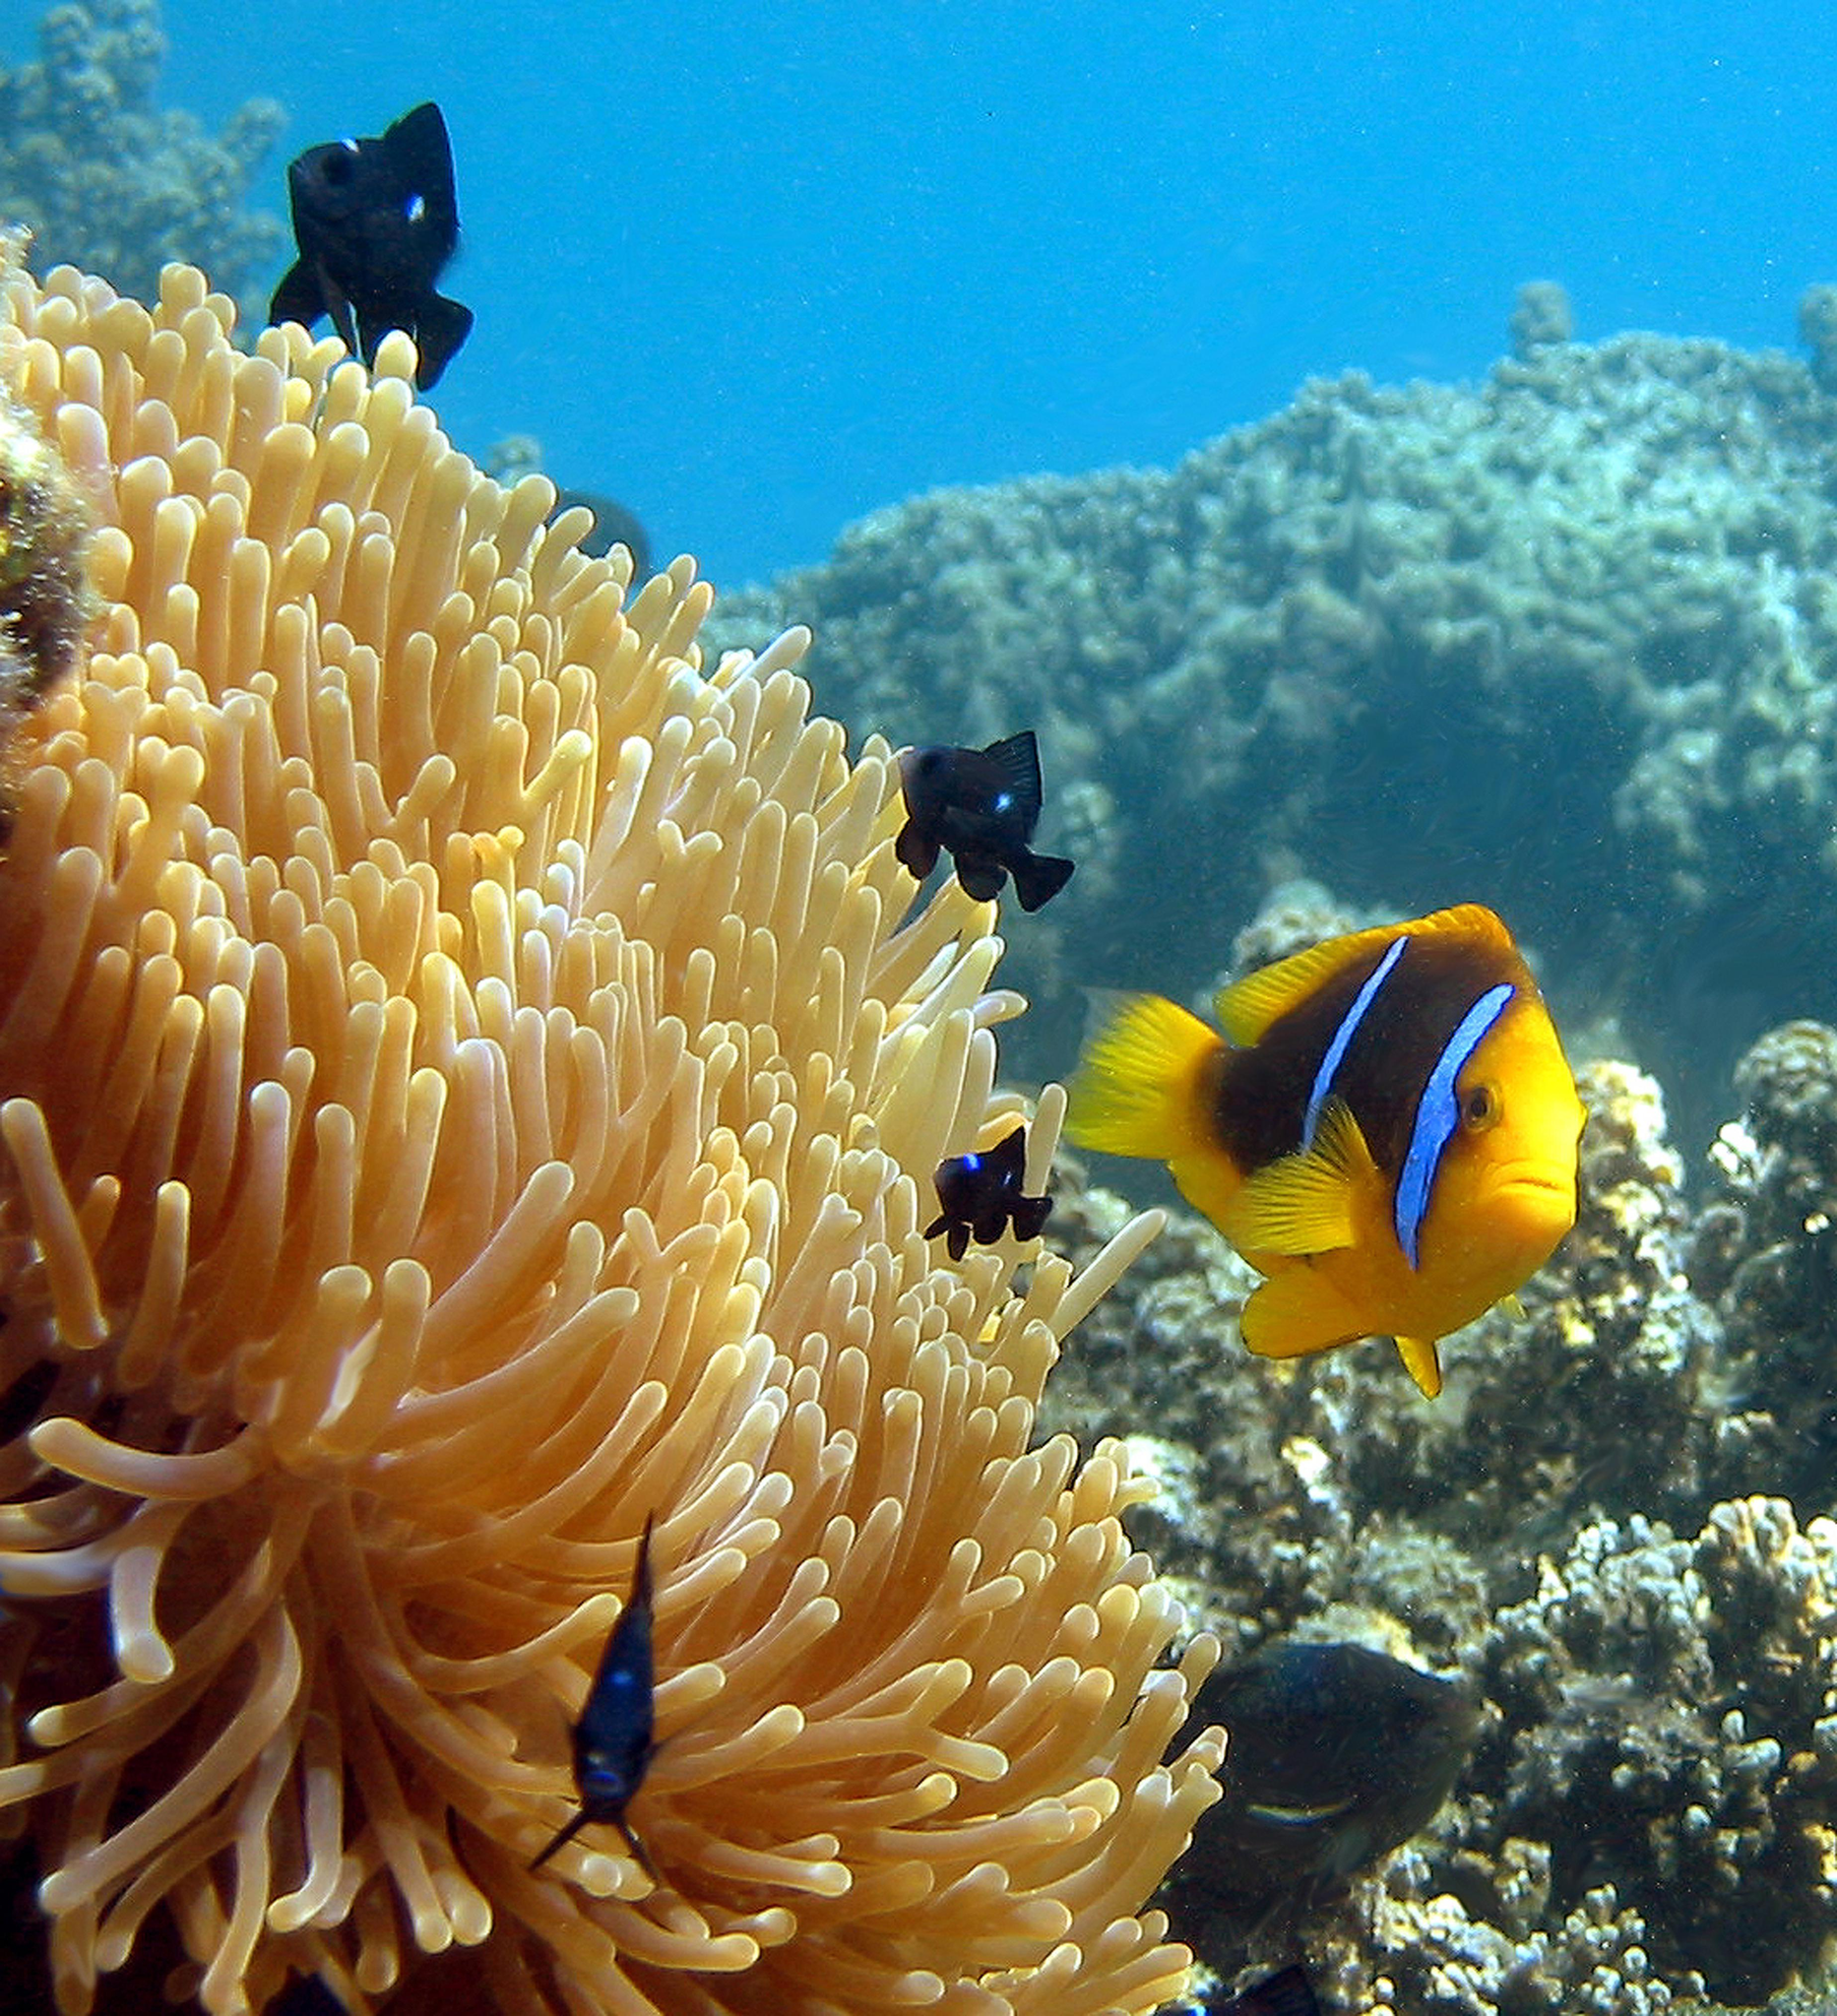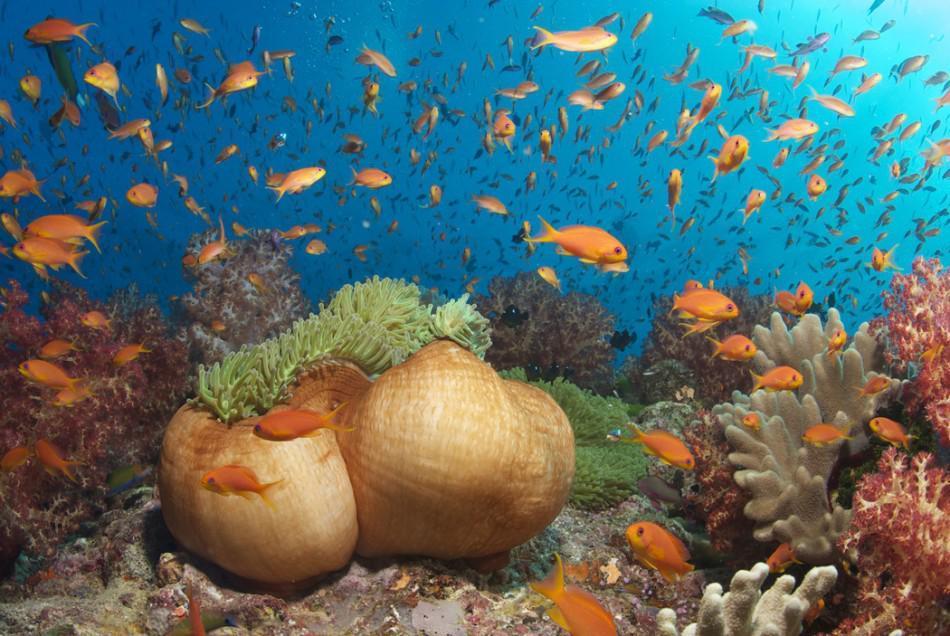The first image is the image on the left, the second image is the image on the right. Given the left and right images, does the statement "No fish are swimming near anemone in at least one image, and in one image the anemone has tendrils that are at least partly purple, while the other image shows neutral-colored anemone." hold true? Answer yes or no. No. 